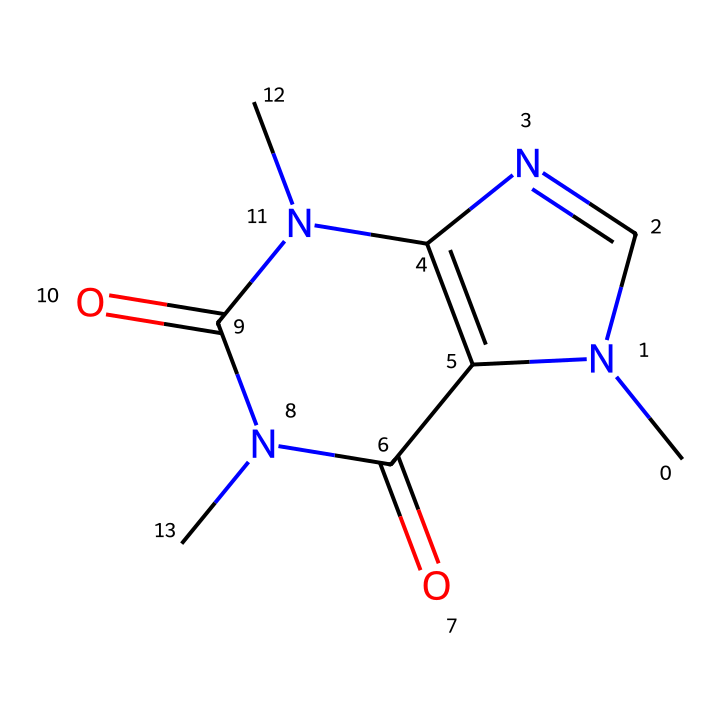What is the molecular formula of caffeine? To derive the molecular formula from the SMILES, identify the atoms represented: there are 8 carbon (C) atoms, 10 hydrogen (H) atoms, and 4 nitrogen (N) atoms, along with 2 oxygen (O) atoms. Thus, combining these gives the formula C8H10N4O2.
Answer: C8H10N4O2 How many nitrogen atoms are present in caffeine? From analyzing the SMILES, we can count the nitrogen atoms (N). The total count observed in the structure is 4.
Answer: 4 What functional groups are present in caffeine? Examining the SMILES, caffeine contains functional groups such as amines (due to nitrogen atoms) and carbonyls (due to the presence of oxygen atoms in double bond configurations).
Answer: amine, carbonyl Is caffeine a saturated or unsaturated compound? The presence of double bonds in the structure (indicated by the "=" sign in the SMILES) suggests that caffeine does not have all single bonds, implying that it is unsaturated.
Answer: unsaturated What type of compound is caffeine classified as? Caffeine is classified as an alkaloid, which is a group of nitrogen-containing compounds. This identification comes from the presence of multiple nitrogen atoms in the structure.
Answer: alkaloid How many rings are in the caffeine structure? By analyzing the connections in the SMILES, it can be observed that there are two fused rings in the structure of caffeine, indicating its bicyclic nature.
Answer: 2 What is the impact of the nitrogen atoms on caffeine's properties? The nitrogen atoms contribute to the basic nature of caffeine, influencing the molecule's ability to act as a stimulant and interact with neuronal receptors, thus enhancing its pharmacological effects.
Answer: stimulant 